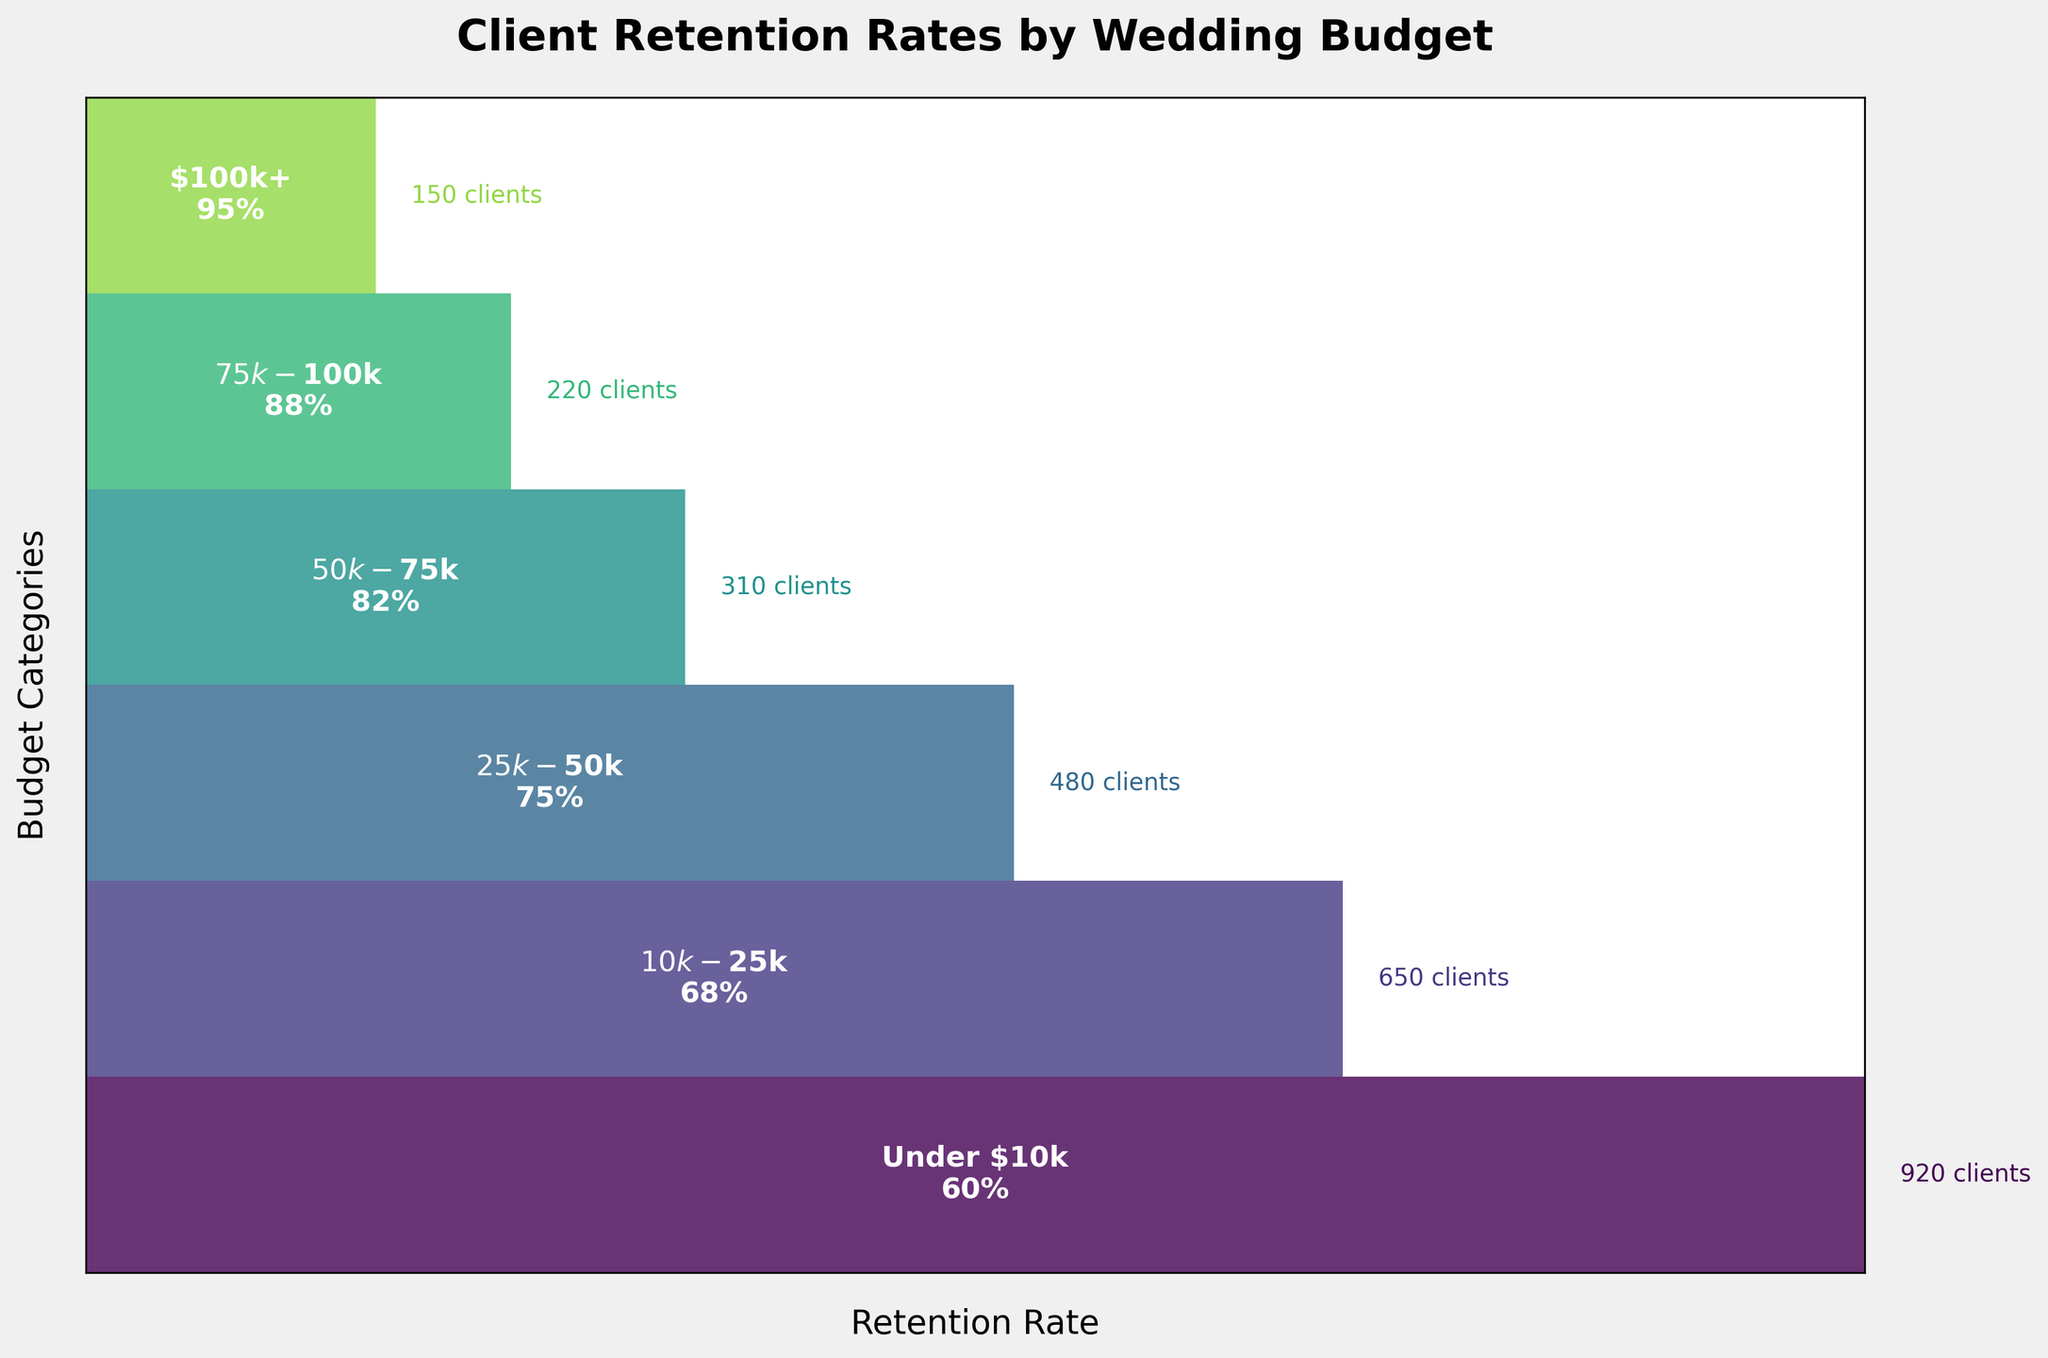What is the title of the figure? The title can be found at the top of the chart. It is generally in bold and larger font.
Answer: Client Retention Rates by Wedding Budget What are the budget categories shown in the figure? The budget categories can be seen as labels alongside each section of the funnel chart.
Answer: $100k+, $75k-$100k, $50k-$75k, $25k-$50k, $10k-$25k, Under $10k Which budget category has the highest client retention rate? To identify the highest retention rate, look for the section with the highest percentage value.
Answer: $100k+ Which budget category has the most clients? To find the category with the most clients, locate the widest section of the funnel.
Answer: Under $10k What is the retention rate for clients with a wedding budget under $10k? Find the section labeled "Under $10k" and read the retention rate given in percentage.
Answer: 60% How does the retention rate change as the budget category decreases? Observe the retention rates from highest to lowest budget categories. Note if the retention rate increases, decreases, or stays the same as the budget category decreases.
Answer: It decreases What is the difference in the number of clients between the $100k+ category and the $10k-$25k category? Subtract the number of clients in the $100k+ category from the number of clients in the $10k-$25k category.
Answer: 650 - 150 = 500 Which budget category has a retention rate closest to 80%? Look for the category whose retention rate is nearest to 80%.
Answer: $50k-$75k How many clients do the top three budget categories together represent? Add the number of clients in the $100k+, $75k-$100k, and $50k-$75k categories.
Answer: 150 + 220 + 310 = 680 Is there a budget category where the retention rate drops by more than 10% compared to the previous category? Check each successive pair of categories for a drop in retention rates greater than 10%.
Answer: Between $75k-$100k (88%) and $50k-$75k (82%), which is a drop of 6%, no: but between $25k-$50k (75%) and $10k-$25k (68%), which is 7% and between $10k-$25k (68%) and Under $10k (60%), which is 8%, yes 